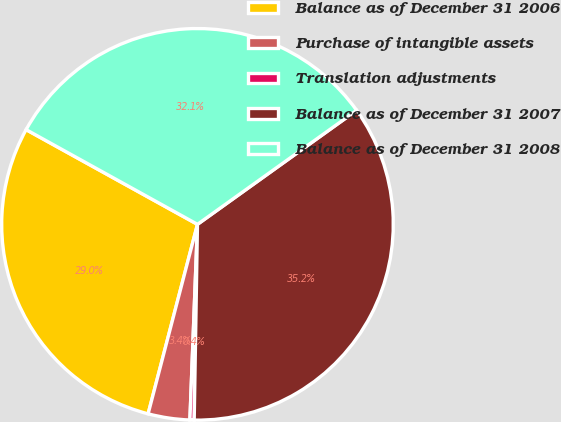Convert chart. <chart><loc_0><loc_0><loc_500><loc_500><pie_chart><fcel>Balance as of December 31 2006<fcel>Purchase of intangible assets<fcel>Translation adjustments<fcel>Balance as of December 31 2007<fcel>Balance as of December 31 2008<nl><fcel>28.98%<fcel>3.44%<fcel>0.35%<fcel>35.16%<fcel>32.07%<nl></chart> 